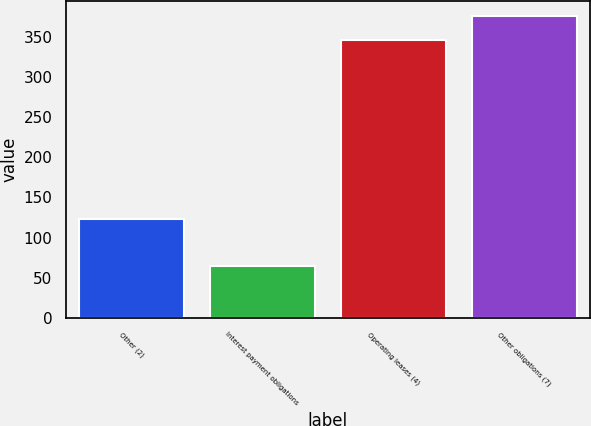<chart> <loc_0><loc_0><loc_500><loc_500><bar_chart><fcel>Other (2)<fcel>Interest payment obligations<fcel>Operating leases (4)<fcel>Other obligations (7)<nl><fcel>123<fcel>65<fcel>346<fcel>376<nl></chart> 